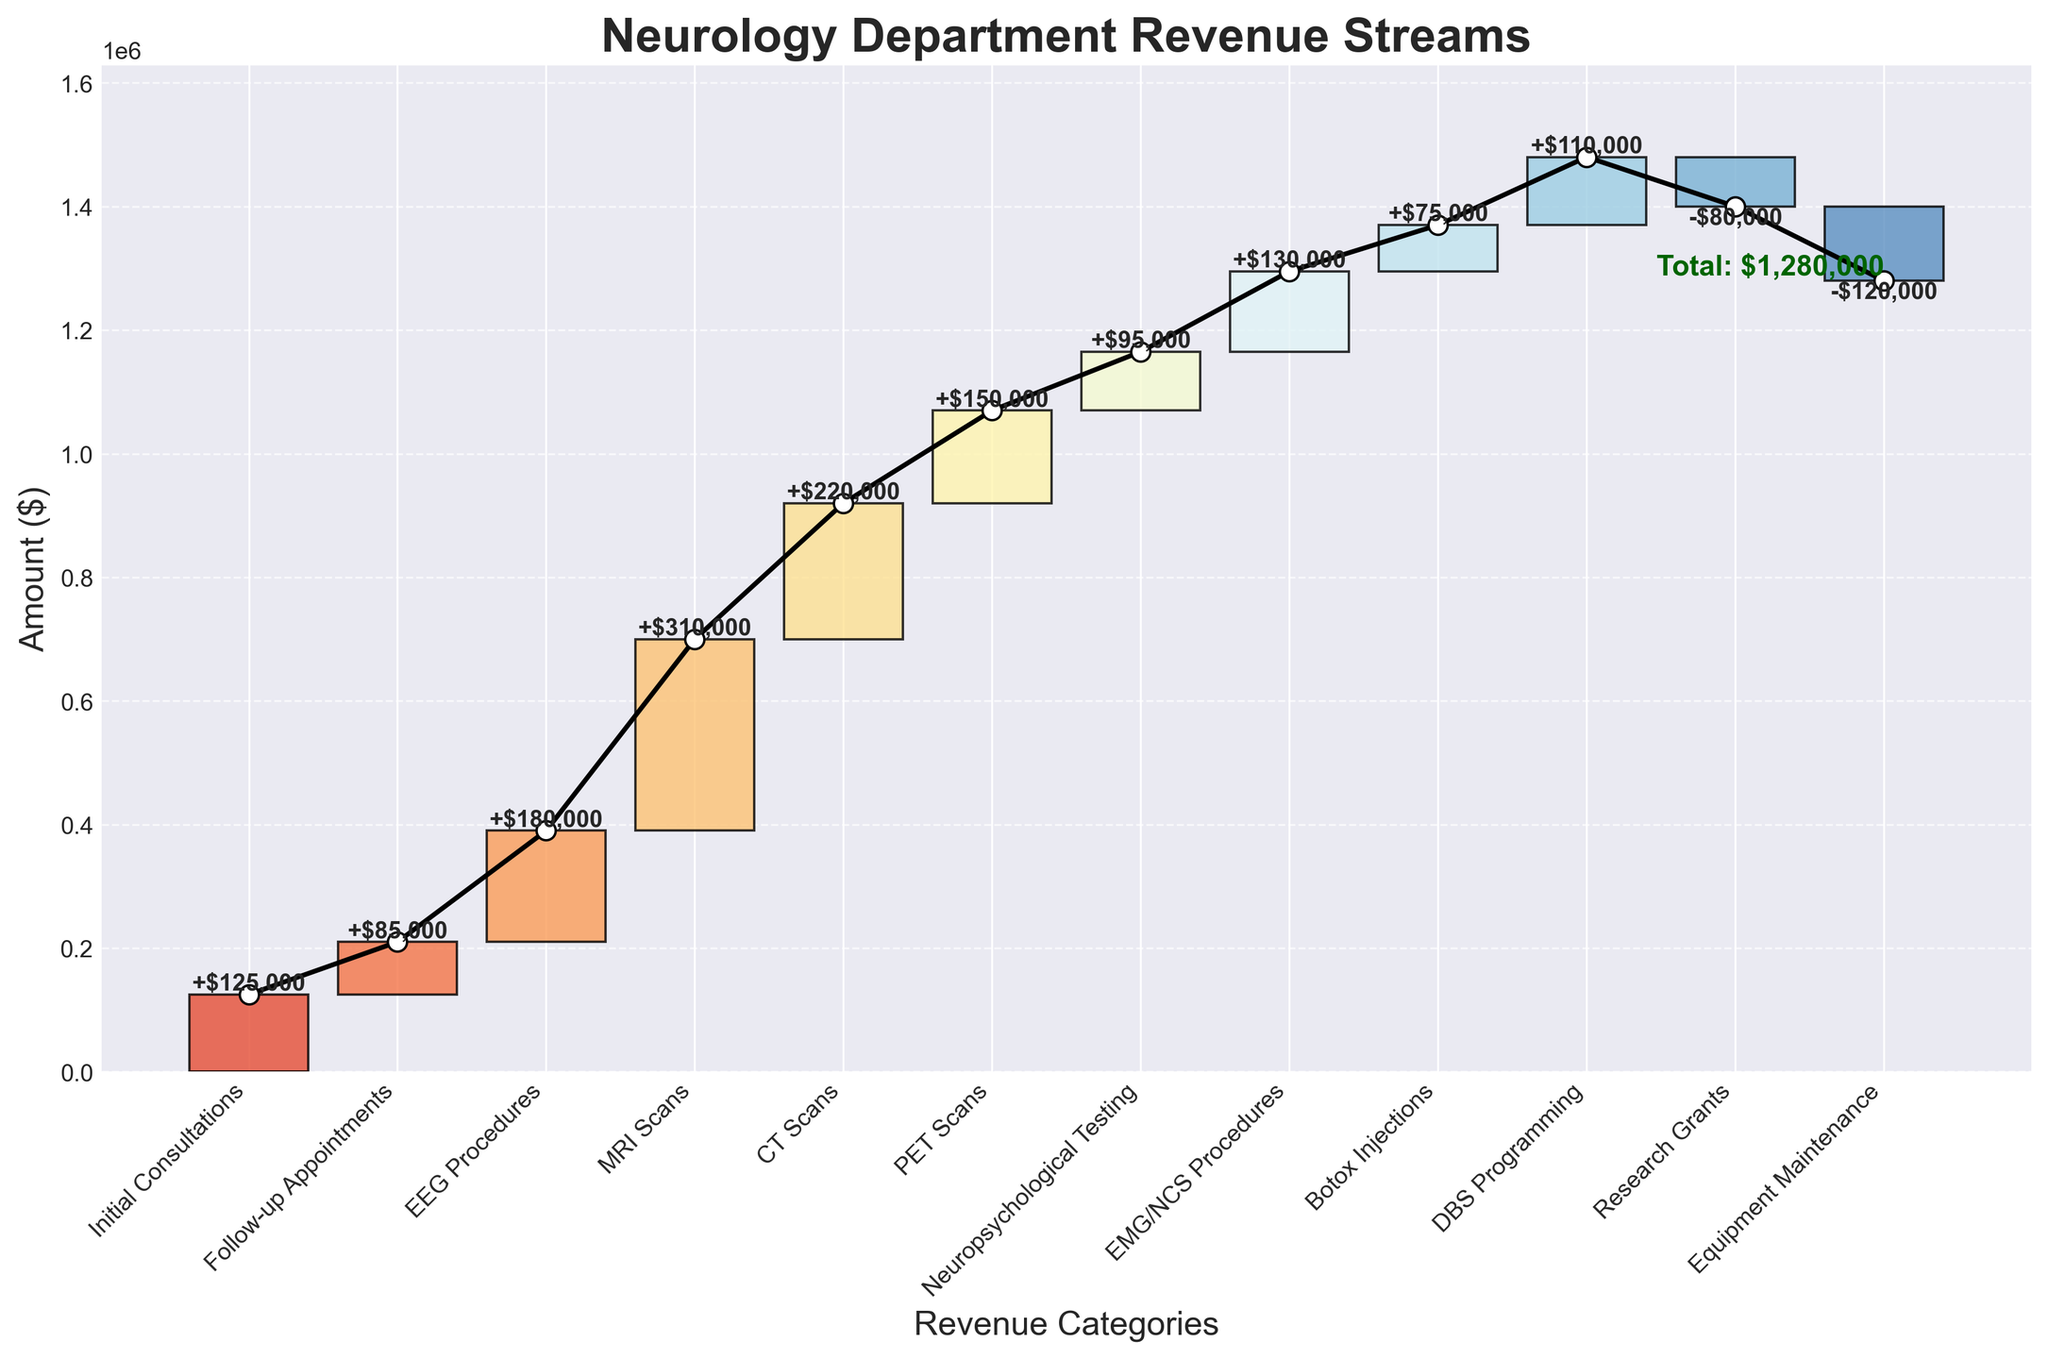What is the total revenue mentioned in the chart? The total revenue is explicitly labeled at the end of the cumulative bar and is green in color.
Answer: $1,280,000 How does the revenue from MRI Scans compare to that from PET Scans? The height of the bar for MRI Scans ($310,000) is much higher than that for PET Scans ($150,000).
Answer: $310,000 > $150,000 Which revenue stream contributes the highest amount? By observing the highest bar in the figure, it's clear that MRI Scans contribute the most revenue.
Answer: MRI Scans What is the cumulative revenue just before equipment maintenance expenses? To find the cumulative revenue before equipment maintenance, sum up all the previous values: $125,000 + $85,000 + $180,000 + $310,000 + $220,000 + $150,000 + $95,000 + $130,000 + $75,000 + $110,000 = $1,480,000.
Answer: $1,480,000 What percentage of total revenue comes from EEG Procedures? Percentage = (Amount from EEG Procedures / Total Revenue) * 100 = ($180,000 / $1,280,000) * 100 = 14.06%.
Answer: 14.06% Which categories show a deduction from revenue? The categories with downward-facing bars indicate deductions, which are Research Grants (-$80,000) and Equipment Maintenance (-$120,000).
Answer: Research Grants, Equipment Maintenance Is the revenue from Neuropsychological Testing higher or lower than from Follow-up Appointments, and by how much? Neuropsychological Testing has a revenue of $95,000, whereas Follow-up Appointments have $85,000, making Neuropsychological Testing higher by $10,000.
Answer: Higher by $10,000 What is the net impact of equipment maintenance and research grants on total revenue? Sum these two deductions: -$80,000 + -$120,000 = -$200,000.
Answer: -$200,000 Does the cumulative revenue line ever decrease? By following the cumulative line from start to end, it remains increasing without any dips, as it includes only revenue increments and deductions that are subtracted on paper.
Answer: No 